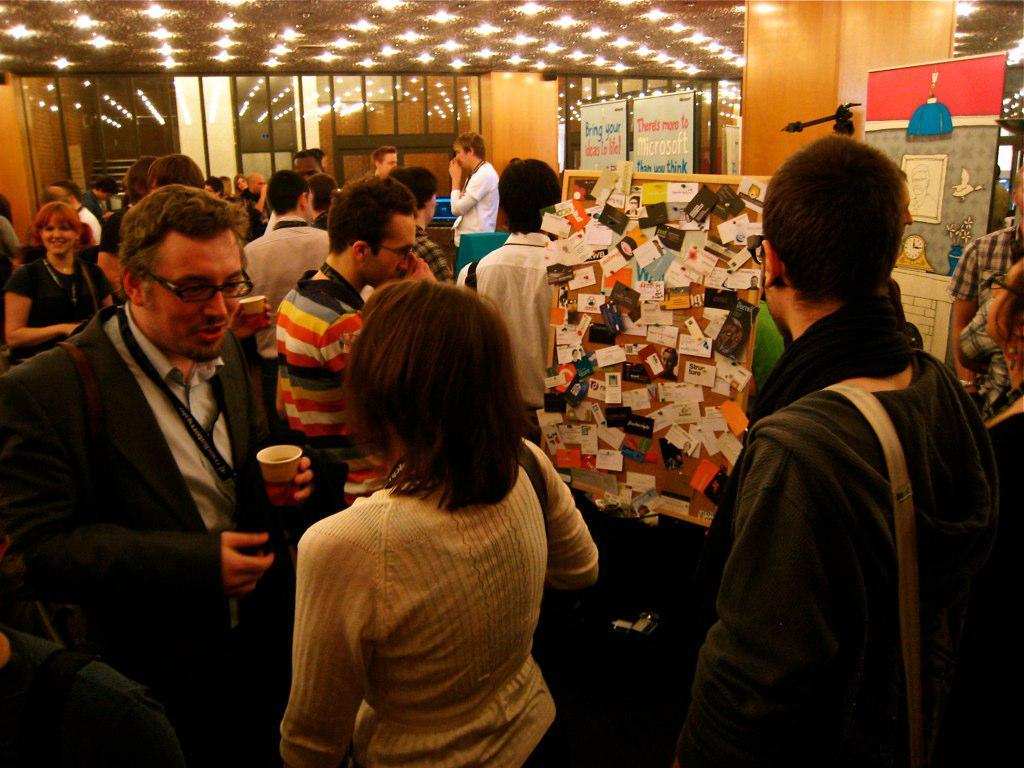What are the people in the middle of the image doing? The people are standing in the middle of the image and holding cups. What else can be seen in the image besides the people? There are banners visible in the image, and there is a wall in the background. What is visible at the top of the image? The ceiling is visible at the top of the image, and there are lights on the ceiling. Can you hear the sound of thunder in the image? There is no sound present in the image, so it is not possible to hear thunder or any other sounds. 